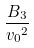Convert formula to latex. <formula><loc_0><loc_0><loc_500><loc_500>\frac { B _ { 3 } } { { v _ { 0 } } ^ { 2 } }</formula> 